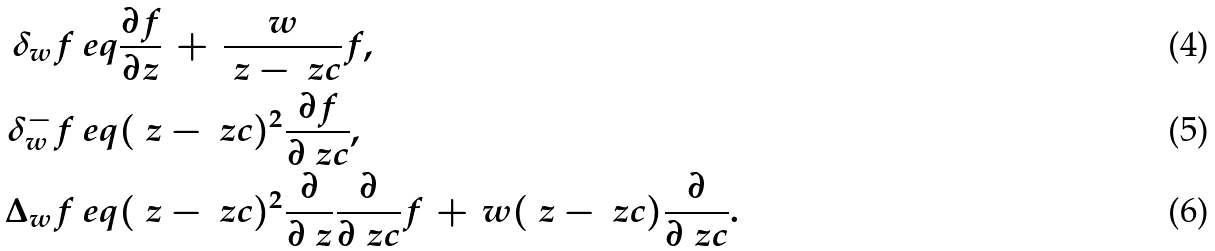<formula> <loc_0><loc_0><loc_500><loc_500>\delta _ { w } f & \ e q \frac { \partial f } { \partial z } \, + \, \frac { w } { \ z - \ z c } f , \\ \delta _ { w } ^ { - } f & \ e q ( \ z - \ z c ) ^ { 2 } \frac { \partial f } { \partial \ z c } , \\ \Delta _ { w } f & \ e q ( \ z - \ z c ) ^ { 2 } \frac { \partial } { \partial \ z } \frac { \partial } { \partial \ z c } f \, + \, w ( \ z - \ z c ) \frac { \partial } { \partial \ z c } .</formula> 